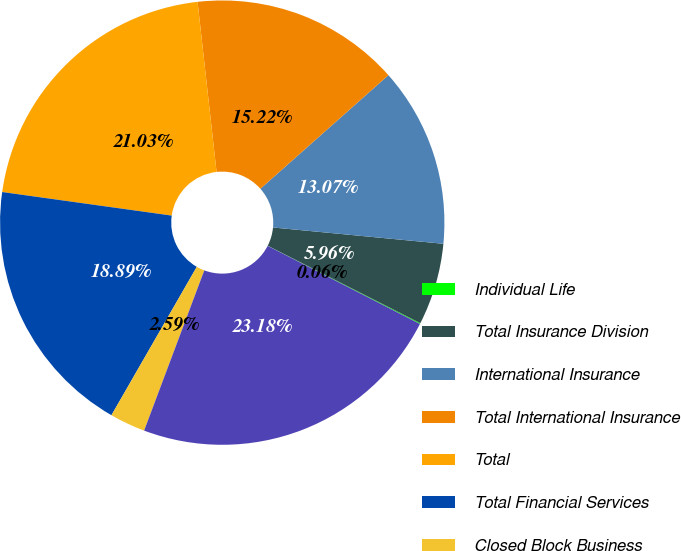<chart> <loc_0><loc_0><loc_500><loc_500><pie_chart><fcel>Individual Life<fcel>Total Insurance Division<fcel>International Insurance<fcel>Total International Insurance<fcel>Total<fcel>Total Financial Services<fcel>Closed Block Business<fcel>Total per Consolidated<nl><fcel>0.06%<fcel>5.96%<fcel>13.07%<fcel>15.22%<fcel>21.03%<fcel>18.89%<fcel>2.59%<fcel>23.18%<nl></chart> 